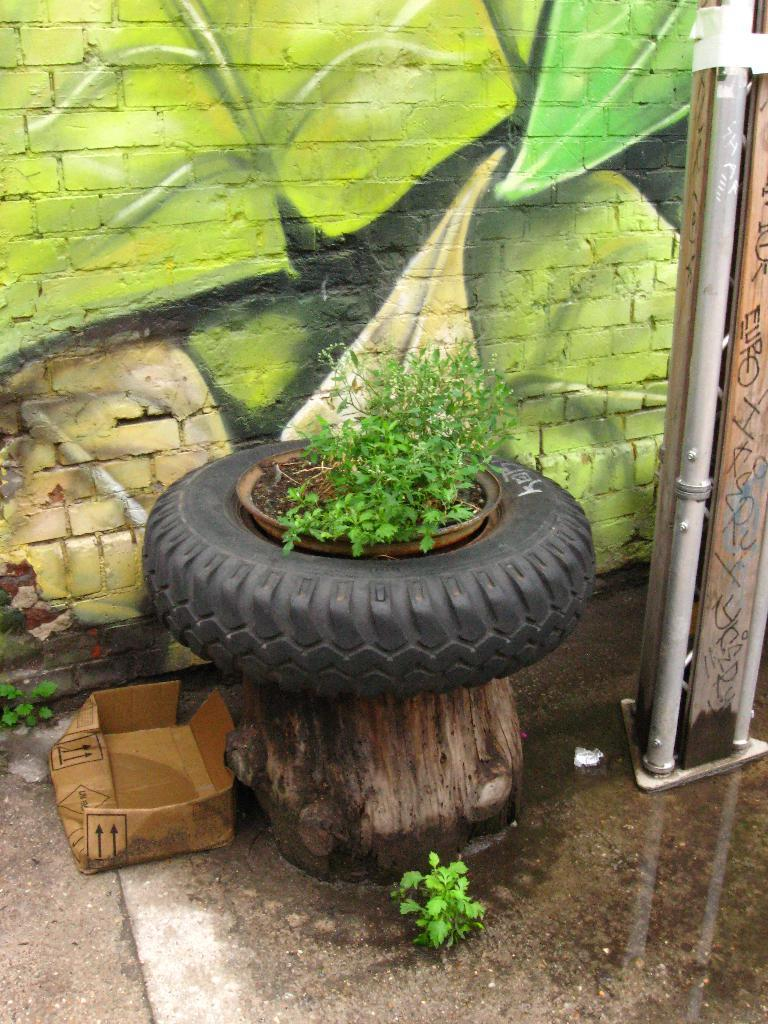What object can be seen in the image that is typically used for transportation? There is a tire in the image, which is commonly used for transportation. What type of plant is visible in the image? There is a house plant in the image. What is the shape of the object that can be seen in the image and is often used for storage? There is a box in the image, which is typically used for storage. What is the long, cylindrical object in the image that is used for transporting fluids? There is a pipe in the image, which is used for transporting fluids. What can be seen on the wall in the background of the image? There is a painting on the wall in the background of the image. What type of record can be seen on the wall in the image? There is no record present in the image; it features a painting on the wall. Who is the creator of the tire in the image? The tire is a manufactured object and does not have a specific creator. 